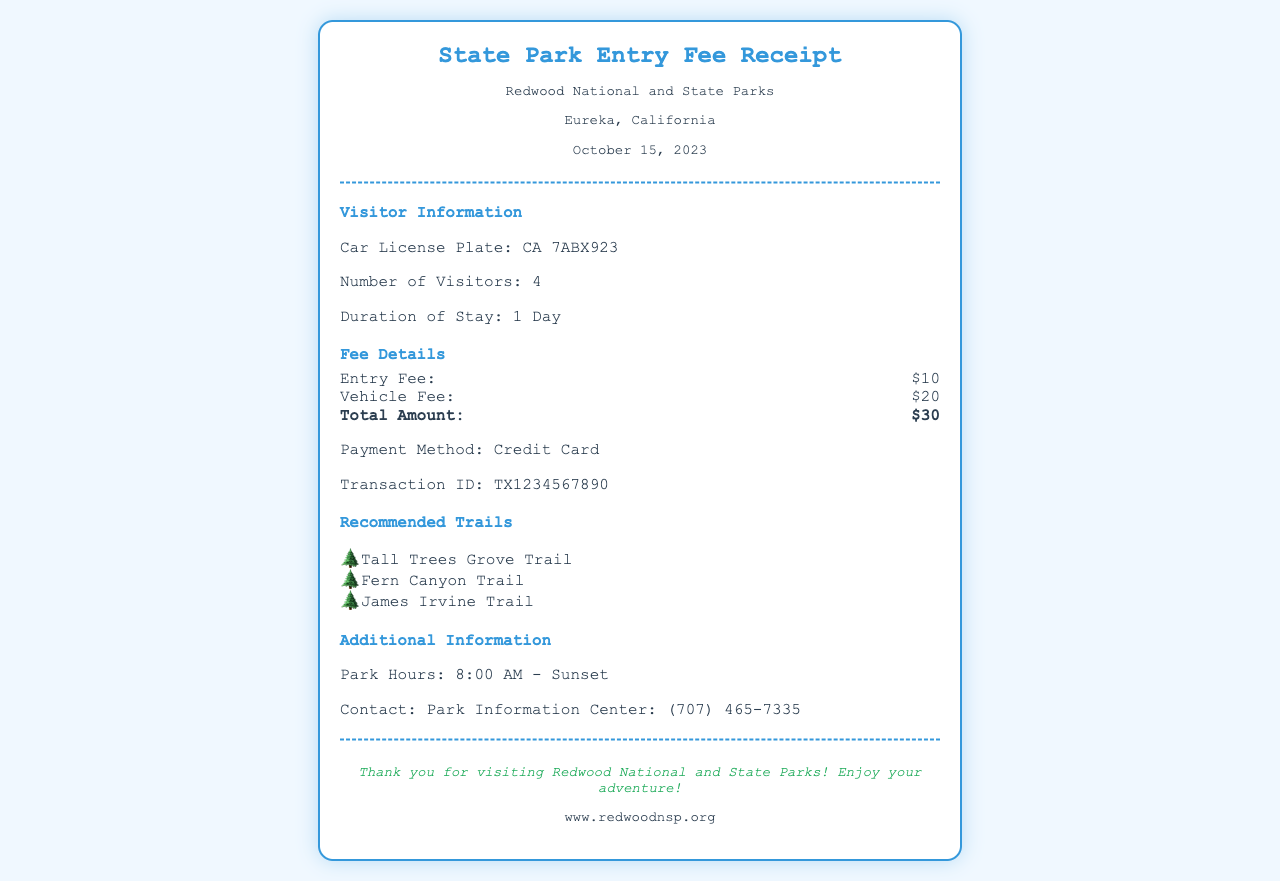What is the car license plate? The car license plate is explicitly stated in the Visitor Information section of the document.
Answer: CA 7ABX923 How many visitors were there? The number of visitors is provided in the Visitor Information section of the document.
Answer: 4 What is the duration of stay? The duration of stay is mentioned in the Visitor Information section as well.
Answer: 1 Day What is the total amount paid? The total amount is calculated from the Fee Details section, which lists the entry and vehicle fees.
Answer: $30 What are the recommended trails? The recommended trails are listed under the Recommended Trails section of the document.
Answer: Tall Trees Grove Trail, Fern Canyon Trail, James Irvine Trail What payment method was used? The payment method is specified in the Fee Details section of the document.
Answer: Credit Card What is the date of the receipt? The date of the receipt is provided in the park information at the top of the document.
Answer: October 15, 2023 What is the contact number for the Park Information Center? The contact number is listed in the Additional Information section of the document.
Answer: (707) 465-7335 